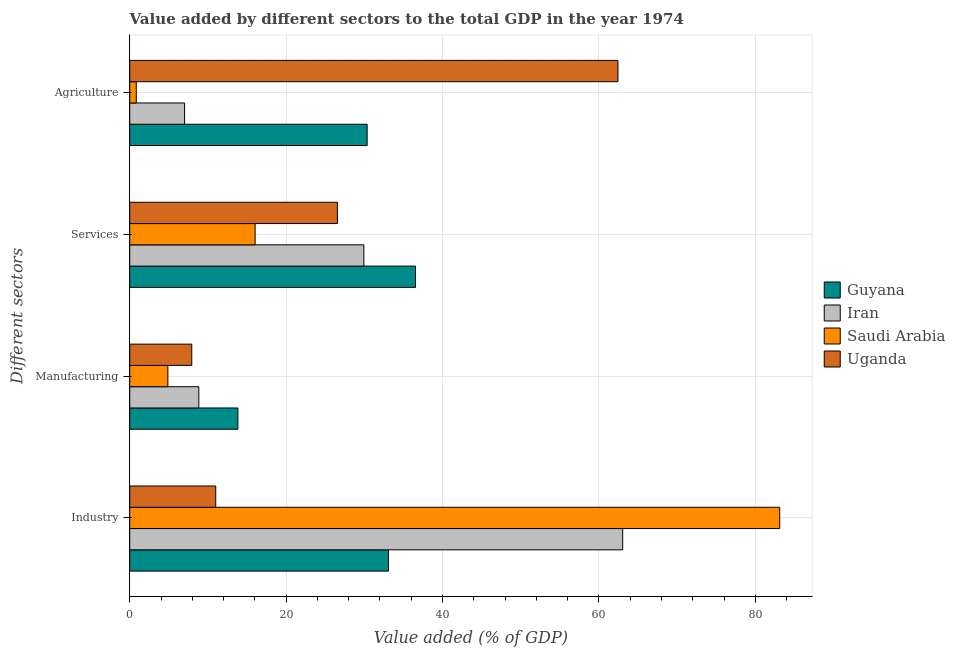How many different coloured bars are there?
Keep it short and to the point. 4. Are the number of bars on each tick of the Y-axis equal?
Your answer should be compact. Yes. How many bars are there on the 4th tick from the top?
Give a very brief answer. 4. How many bars are there on the 4th tick from the bottom?
Give a very brief answer. 4. What is the label of the 2nd group of bars from the top?
Give a very brief answer. Services. What is the value added by industrial sector in Saudi Arabia?
Offer a very short reply. 83.13. Across all countries, what is the maximum value added by services sector?
Keep it short and to the point. 36.55. Across all countries, what is the minimum value added by services sector?
Offer a terse response. 16.04. In which country was the value added by services sector maximum?
Offer a terse response. Guyana. In which country was the value added by manufacturing sector minimum?
Offer a terse response. Saudi Arabia. What is the total value added by services sector in the graph?
Your answer should be compact. 109.09. What is the difference between the value added by manufacturing sector in Saudi Arabia and that in Guyana?
Ensure brevity in your answer.  -8.95. What is the difference between the value added by manufacturing sector in Uganda and the value added by agricultural sector in Saudi Arabia?
Ensure brevity in your answer.  7.1. What is the average value added by services sector per country?
Your answer should be compact. 27.27. What is the difference between the value added by manufacturing sector and value added by agricultural sector in Uganda?
Your response must be concise. -54.5. What is the ratio of the value added by agricultural sector in Guyana to that in Uganda?
Ensure brevity in your answer.  0.49. Is the value added by industrial sector in Guyana less than that in Iran?
Your response must be concise. Yes. What is the difference between the highest and the second highest value added by industrial sector?
Provide a succinct answer. 20.08. What is the difference between the highest and the lowest value added by industrial sector?
Your response must be concise. 72.13. Is the sum of the value added by services sector in Uganda and Iran greater than the maximum value added by manufacturing sector across all countries?
Make the answer very short. Yes. What does the 4th bar from the top in Agriculture represents?
Your answer should be compact. Guyana. What does the 4th bar from the bottom in Agriculture represents?
Give a very brief answer. Uganda. Is it the case that in every country, the sum of the value added by industrial sector and value added by manufacturing sector is greater than the value added by services sector?
Ensure brevity in your answer.  No. How many bars are there?
Your response must be concise. 16. What is the difference between two consecutive major ticks on the X-axis?
Ensure brevity in your answer.  20. Are the values on the major ticks of X-axis written in scientific E-notation?
Provide a succinct answer. No. Does the graph contain any zero values?
Make the answer very short. No. Where does the legend appear in the graph?
Make the answer very short. Center right. How are the legend labels stacked?
Offer a terse response. Vertical. What is the title of the graph?
Make the answer very short. Value added by different sectors to the total GDP in the year 1974. What is the label or title of the X-axis?
Provide a succinct answer. Value added (% of GDP). What is the label or title of the Y-axis?
Make the answer very short. Different sectors. What is the Value added (% of GDP) of Guyana in Industry?
Provide a succinct answer. 33.09. What is the Value added (% of GDP) in Iran in Industry?
Offer a very short reply. 63.04. What is the Value added (% of GDP) in Saudi Arabia in Industry?
Your answer should be compact. 83.13. What is the Value added (% of GDP) in Uganda in Industry?
Keep it short and to the point. 11. What is the Value added (% of GDP) in Guyana in Manufacturing?
Make the answer very short. 13.83. What is the Value added (% of GDP) in Iran in Manufacturing?
Provide a succinct answer. 8.84. What is the Value added (% of GDP) in Saudi Arabia in Manufacturing?
Your answer should be very brief. 4.88. What is the Value added (% of GDP) of Uganda in Manufacturing?
Make the answer very short. 7.94. What is the Value added (% of GDP) in Guyana in Services?
Ensure brevity in your answer.  36.55. What is the Value added (% of GDP) in Iran in Services?
Your response must be concise. 29.94. What is the Value added (% of GDP) in Saudi Arabia in Services?
Offer a terse response. 16.04. What is the Value added (% of GDP) of Uganda in Services?
Provide a short and direct response. 26.56. What is the Value added (% of GDP) in Guyana in Agriculture?
Make the answer very short. 30.36. What is the Value added (% of GDP) in Iran in Agriculture?
Offer a terse response. 7.01. What is the Value added (% of GDP) in Saudi Arabia in Agriculture?
Keep it short and to the point. 0.84. What is the Value added (% of GDP) of Uganda in Agriculture?
Offer a very short reply. 62.44. Across all Different sectors, what is the maximum Value added (% of GDP) in Guyana?
Your answer should be compact. 36.55. Across all Different sectors, what is the maximum Value added (% of GDP) in Iran?
Offer a terse response. 63.04. Across all Different sectors, what is the maximum Value added (% of GDP) in Saudi Arabia?
Your answer should be very brief. 83.13. Across all Different sectors, what is the maximum Value added (% of GDP) in Uganda?
Offer a very short reply. 62.44. Across all Different sectors, what is the minimum Value added (% of GDP) of Guyana?
Ensure brevity in your answer.  13.83. Across all Different sectors, what is the minimum Value added (% of GDP) of Iran?
Your answer should be compact. 7.01. Across all Different sectors, what is the minimum Value added (% of GDP) in Saudi Arabia?
Offer a very short reply. 0.84. Across all Different sectors, what is the minimum Value added (% of GDP) in Uganda?
Provide a succinct answer. 7.94. What is the total Value added (% of GDP) of Guyana in the graph?
Keep it short and to the point. 113.83. What is the total Value added (% of GDP) in Iran in the graph?
Your answer should be compact. 108.84. What is the total Value added (% of GDP) in Saudi Arabia in the graph?
Offer a terse response. 104.88. What is the total Value added (% of GDP) in Uganda in the graph?
Your answer should be compact. 107.94. What is the difference between the Value added (% of GDP) in Guyana in Industry and that in Manufacturing?
Provide a short and direct response. 19.26. What is the difference between the Value added (% of GDP) of Iran in Industry and that in Manufacturing?
Make the answer very short. 54.21. What is the difference between the Value added (% of GDP) in Saudi Arabia in Industry and that in Manufacturing?
Your response must be concise. 78.25. What is the difference between the Value added (% of GDP) of Uganda in Industry and that in Manufacturing?
Your answer should be compact. 3.06. What is the difference between the Value added (% of GDP) of Guyana in Industry and that in Services?
Give a very brief answer. -3.46. What is the difference between the Value added (% of GDP) of Iran in Industry and that in Services?
Ensure brevity in your answer.  33.1. What is the difference between the Value added (% of GDP) of Saudi Arabia in Industry and that in Services?
Give a very brief answer. 67.09. What is the difference between the Value added (% of GDP) of Uganda in Industry and that in Services?
Keep it short and to the point. -15.56. What is the difference between the Value added (% of GDP) of Guyana in Industry and that in Agriculture?
Keep it short and to the point. 2.72. What is the difference between the Value added (% of GDP) in Iran in Industry and that in Agriculture?
Keep it short and to the point. 56.03. What is the difference between the Value added (% of GDP) in Saudi Arabia in Industry and that in Agriculture?
Make the answer very short. 82.29. What is the difference between the Value added (% of GDP) in Uganda in Industry and that in Agriculture?
Make the answer very short. -51.44. What is the difference between the Value added (% of GDP) of Guyana in Manufacturing and that in Services?
Offer a very short reply. -22.72. What is the difference between the Value added (% of GDP) in Iran in Manufacturing and that in Services?
Your response must be concise. -21.11. What is the difference between the Value added (% of GDP) of Saudi Arabia in Manufacturing and that in Services?
Give a very brief answer. -11.16. What is the difference between the Value added (% of GDP) in Uganda in Manufacturing and that in Services?
Make the answer very short. -18.62. What is the difference between the Value added (% of GDP) of Guyana in Manufacturing and that in Agriculture?
Your response must be concise. -16.53. What is the difference between the Value added (% of GDP) in Iran in Manufacturing and that in Agriculture?
Keep it short and to the point. 1.83. What is the difference between the Value added (% of GDP) in Saudi Arabia in Manufacturing and that in Agriculture?
Give a very brief answer. 4.04. What is the difference between the Value added (% of GDP) of Uganda in Manufacturing and that in Agriculture?
Make the answer very short. -54.5. What is the difference between the Value added (% of GDP) of Guyana in Services and that in Agriculture?
Your response must be concise. 6.19. What is the difference between the Value added (% of GDP) of Iran in Services and that in Agriculture?
Make the answer very short. 22.93. What is the difference between the Value added (% of GDP) of Saudi Arabia in Services and that in Agriculture?
Your answer should be very brief. 15.2. What is the difference between the Value added (% of GDP) of Uganda in Services and that in Agriculture?
Provide a succinct answer. -35.88. What is the difference between the Value added (% of GDP) of Guyana in Industry and the Value added (% of GDP) of Iran in Manufacturing?
Your answer should be compact. 24.25. What is the difference between the Value added (% of GDP) of Guyana in Industry and the Value added (% of GDP) of Saudi Arabia in Manufacturing?
Provide a succinct answer. 28.21. What is the difference between the Value added (% of GDP) of Guyana in Industry and the Value added (% of GDP) of Uganda in Manufacturing?
Keep it short and to the point. 25.15. What is the difference between the Value added (% of GDP) of Iran in Industry and the Value added (% of GDP) of Saudi Arabia in Manufacturing?
Give a very brief answer. 58.16. What is the difference between the Value added (% of GDP) in Iran in Industry and the Value added (% of GDP) in Uganda in Manufacturing?
Give a very brief answer. 55.11. What is the difference between the Value added (% of GDP) of Saudi Arabia in Industry and the Value added (% of GDP) of Uganda in Manufacturing?
Give a very brief answer. 75.19. What is the difference between the Value added (% of GDP) of Guyana in Industry and the Value added (% of GDP) of Iran in Services?
Your answer should be very brief. 3.14. What is the difference between the Value added (% of GDP) in Guyana in Industry and the Value added (% of GDP) in Saudi Arabia in Services?
Your response must be concise. 17.05. What is the difference between the Value added (% of GDP) in Guyana in Industry and the Value added (% of GDP) in Uganda in Services?
Keep it short and to the point. 6.53. What is the difference between the Value added (% of GDP) of Iran in Industry and the Value added (% of GDP) of Saudi Arabia in Services?
Make the answer very short. 47.01. What is the difference between the Value added (% of GDP) in Iran in Industry and the Value added (% of GDP) in Uganda in Services?
Offer a terse response. 36.48. What is the difference between the Value added (% of GDP) of Saudi Arabia in Industry and the Value added (% of GDP) of Uganda in Services?
Offer a terse response. 56.57. What is the difference between the Value added (% of GDP) in Guyana in Industry and the Value added (% of GDP) in Iran in Agriculture?
Ensure brevity in your answer.  26.08. What is the difference between the Value added (% of GDP) in Guyana in Industry and the Value added (% of GDP) in Saudi Arabia in Agriculture?
Make the answer very short. 32.25. What is the difference between the Value added (% of GDP) of Guyana in Industry and the Value added (% of GDP) of Uganda in Agriculture?
Offer a very short reply. -29.35. What is the difference between the Value added (% of GDP) of Iran in Industry and the Value added (% of GDP) of Saudi Arabia in Agriculture?
Your response must be concise. 62.21. What is the difference between the Value added (% of GDP) in Iran in Industry and the Value added (% of GDP) in Uganda in Agriculture?
Keep it short and to the point. 0.61. What is the difference between the Value added (% of GDP) in Saudi Arabia in Industry and the Value added (% of GDP) in Uganda in Agriculture?
Make the answer very short. 20.69. What is the difference between the Value added (% of GDP) in Guyana in Manufacturing and the Value added (% of GDP) in Iran in Services?
Provide a short and direct response. -16.11. What is the difference between the Value added (% of GDP) of Guyana in Manufacturing and the Value added (% of GDP) of Saudi Arabia in Services?
Offer a terse response. -2.21. What is the difference between the Value added (% of GDP) in Guyana in Manufacturing and the Value added (% of GDP) in Uganda in Services?
Your response must be concise. -12.73. What is the difference between the Value added (% of GDP) in Iran in Manufacturing and the Value added (% of GDP) in Saudi Arabia in Services?
Offer a very short reply. -7.2. What is the difference between the Value added (% of GDP) of Iran in Manufacturing and the Value added (% of GDP) of Uganda in Services?
Your answer should be compact. -17.72. What is the difference between the Value added (% of GDP) of Saudi Arabia in Manufacturing and the Value added (% of GDP) of Uganda in Services?
Make the answer very short. -21.68. What is the difference between the Value added (% of GDP) of Guyana in Manufacturing and the Value added (% of GDP) of Iran in Agriculture?
Ensure brevity in your answer.  6.82. What is the difference between the Value added (% of GDP) of Guyana in Manufacturing and the Value added (% of GDP) of Saudi Arabia in Agriculture?
Your answer should be very brief. 13. What is the difference between the Value added (% of GDP) of Guyana in Manufacturing and the Value added (% of GDP) of Uganda in Agriculture?
Keep it short and to the point. -48.61. What is the difference between the Value added (% of GDP) in Iran in Manufacturing and the Value added (% of GDP) in Saudi Arabia in Agriculture?
Provide a short and direct response. 8. What is the difference between the Value added (% of GDP) of Iran in Manufacturing and the Value added (% of GDP) of Uganda in Agriculture?
Ensure brevity in your answer.  -53.6. What is the difference between the Value added (% of GDP) in Saudi Arabia in Manufacturing and the Value added (% of GDP) in Uganda in Agriculture?
Ensure brevity in your answer.  -57.56. What is the difference between the Value added (% of GDP) of Guyana in Services and the Value added (% of GDP) of Iran in Agriculture?
Offer a terse response. 29.54. What is the difference between the Value added (% of GDP) in Guyana in Services and the Value added (% of GDP) in Saudi Arabia in Agriculture?
Your response must be concise. 35.71. What is the difference between the Value added (% of GDP) of Guyana in Services and the Value added (% of GDP) of Uganda in Agriculture?
Offer a very short reply. -25.89. What is the difference between the Value added (% of GDP) in Iran in Services and the Value added (% of GDP) in Saudi Arabia in Agriculture?
Your answer should be compact. 29.11. What is the difference between the Value added (% of GDP) of Iran in Services and the Value added (% of GDP) of Uganda in Agriculture?
Offer a terse response. -32.5. What is the difference between the Value added (% of GDP) of Saudi Arabia in Services and the Value added (% of GDP) of Uganda in Agriculture?
Your answer should be very brief. -46.4. What is the average Value added (% of GDP) of Guyana per Different sectors?
Make the answer very short. 28.46. What is the average Value added (% of GDP) in Iran per Different sectors?
Ensure brevity in your answer.  27.21. What is the average Value added (% of GDP) of Saudi Arabia per Different sectors?
Provide a succinct answer. 26.22. What is the average Value added (% of GDP) of Uganda per Different sectors?
Your answer should be very brief. 26.98. What is the difference between the Value added (% of GDP) in Guyana and Value added (% of GDP) in Iran in Industry?
Ensure brevity in your answer.  -29.96. What is the difference between the Value added (% of GDP) of Guyana and Value added (% of GDP) of Saudi Arabia in Industry?
Give a very brief answer. -50.04. What is the difference between the Value added (% of GDP) in Guyana and Value added (% of GDP) in Uganda in Industry?
Give a very brief answer. 22.09. What is the difference between the Value added (% of GDP) of Iran and Value added (% of GDP) of Saudi Arabia in Industry?
Provide a succinct answer. -20.08. What is the difference between the Value added (% of GDP) in Iran and Value added (% of GDP) in Uganda in Industry?
Give a very brief answer. 52.04. What is the difference between the Value added (% of GDP) of Saudi Arabia and Value added (% of GDP) of Uganda in Industry?
Provide a short and direct response. 72.13. What is the difference between the Value added (% of GDP) of Guyana and Value added (% of GDP) of Iran in Manufacturing?
Offer a terse response. 4.99. What is the difference between the Value added (% of GDP) in Guyana and Value added (% of GDP) in Saudi Arabia in Manufacturing?
Offer a terse response. 8.95. What is the difference between the Value added (% of GDP) of Guyana and Value added (% of GDP) of Uganda in Manufacturing?
Give a very brief answer. 5.89. What is the difference between the Value added (% of GDP) in Iran and Value added (% of GDP) in Saudi Arabia in Manufacturing?
Make the answer very short. 3.96. What is the difference between the Value added (% of GDP) of Iran and Value added (% of GDP) of Uganda in Manufacturing?
Your answer should be compact. 0.9. What is the difference between the Value added (% of GDP) in Saudi Arabia and Value added (% of GDP) in Uganda in Manufacturing?
Your answer should be compact. -3.06. What is the difference between the Value added (% of GDP) in Guyana and Value added (% of GDP) in Iran in Services?
Ensure brevity in your answer.  6.61. What is the difference between the Value added (% of GDP) of Guyana and Value added (% of GDP) of Saudi Arabia in Services?
Provide a succinct answer. 20.51. What is the difference between the Value added (% of GDP) of Guyana and Value added (% of GDP) of Uganda in Services?
Give a very brief answer. 9.99. What is the difference between the Value added (% of GDP) in Iran and Value added (% of GDP) in Saudi Arabia in Services?
Keep it short and to the point. 13.91. What is the difference between the Value added (% of GDP) of Iran and Value added (% of GDP) of Uganda in Services?
Your answer should be compact. 3.38. What is the difference between the Value added (% of GDP) in Saudi Arabia and Value added (% of GDP) in Uganda in Services?
Keep it short and to the point. -10.52. What is the difference between the Value added (% of GDP) in Guyana and Value added (% of GDP) in Iran in Agriculture?
Your response must be concise. 23.35. What is the difference between the Value added (% of GDP) of Guyana and Value added (% of GDP) of Saudi Arabia in Agriculture?
Your response must be concise. 29.53. What is the difference between the Value added (% of GDP) in Guyana and Value added (% of GDP) in Uganda in Agriculture?
Keep it short and to the point. -32.08. What is the difference between the Value added (% of GDP) in Iran and Value added (% of GDP) in Saudi Arabia in Agriculture?
Ensure brevity in your answer.  6.18. What is the difference between the Value added (% of GDP) in Iran and Value added (% of GDP) in Uganda in Agriculture?
Keep it short and to the point. -55.43. What is the difference between the Value added (% of GDP) of Saudi Arabia and Value added (% of GDP) of Uganda in Agriculture?
Your response must be concise. -61.6. What is the ratio of the Value added (% of GDP) in Guyana in Industry to that in Manufacturing?
Make the answer very short. 2.39. What is the ratio of the Value added (% of GDP) in Iran in Industry to that in Manufacturing?
Your answer should be very brief. 7.13. What is the ratio of the Value added (% of GDP) in Saudi Arabia in Industry to that in Manufacturing?
Offer a very short reply. 17.04. What is the ratio of the Value added (% of GDP) in Uganda in Industry to that in Manufacturing?
Offer a terse response. 1.39. What is the ratio of the Value added (% of GDP) of Guyana in Industry to that in Services?
Offer a very short reply. 0.91. What is the ratio of the Value added (% of GDP) of Iran in Industry to that in Services?
Keep it short and to the point. 2.11. What is the ratio of the Value added (% of GDP) in Saudi Arabia in Industry to that in Services?
Make the answer very short. 5.18. What is the ratio of the Value added (% of GDP) in Uganda in Industry to that in Services?
Ensure brevity in your answer.  0.41. What is the ratio of the Value added (% of GDP) of Guyana in Industry to that in Agriculture?
Provide a short and direct response. 1.09. What is the ratio of the Value added (% of GDP) of Iran in Industry to that in Agriculture?
Provide a succinct answer. 8.99. What is the ratio of the Value added (% of GDP) of Saudi Arabia in Industry to that in Agriculture?
Your answer should be compact. 99.49. What is the ratio of the Value added (% of GDP) of Uganda in Industry to that in Agriculture?
Keep it short and to the point. 0.18. What is the ratio of the Value added (% of GDP) in Guyana in Manufacturing to that in Services?
Offer a terse response. 0.38. What is the ratio of the Value added (% of GDP) in Iran in Manufacturing to that in Services?
Make the answer very short. 0.3. What is the ratio of the Value added (% of GDP) in Saudi Arabia in Manufacturing to that in Services?
Provide a succinct answer. 0.3. What is the ratio of the Value added (% of GDP) of Uganda in Manufacturing to that in Services?
Ensure brevity in your answer.  0.3. What is the ratio of the Value added (% of GDP) in Guyana in Manufacturing to that in Agriculture?
Your answer should be compact. 0.46. What is the ratio of the Value added (% of GDP) in Iran in Manufacturing to that in Agriculture?
Give a very brief answer. 1.26. What is the ratio of the Value added (% of GDP) of Saudi Arabia in Manufacturing to that in Agriculture?
Your answer should be compact. 5.84. What is the ratio of the Value added (% of GDP) of Uganda in Manufacturing to that in Agriculture?
Your answer should be very brief. 0.13. What is the ratio of the Value added (% of GDP) of Guyana in Services to that in Agriculture?
Your answer should be very brief. 1.2. What is the ratio of the Value added (% of GDP) in Iran in Services to that in Agriculture?
Your response must be concise. 4.27. What is the ratio of the Value added (% of GDP) in Saudi Arabia in Services to that in Agriculture?
Keep it short and to the point. 19.19. What is the ratio of the Value added (% of GDP) in Uganda in Services to that in Agriculture?
Your response must be concise. 0.43. What is the difference between the highest and the second highest Value added (% of GDP) in Guyana?
Offer a terse response. 3.46. What is the difference between the highest and the second highest Value added (% of GDP) of Iran?
Your answer should be very brief. 33.1. What is the difference between the highest and the second highest Value added (% of GDP) of Saudi Arabia?
Keep it short and to the point. 67.09. What is the difference between the highest and the second highest Value added (% of GDP) of Uganda?
Offer a terse response. 35.88. What is the difference between the highest and the lowest Value added (% of GDP) of Guyana?
Offer a terse response. 22.72. What is the difference between the highest and the lowest Value added (% of GDP) of Iran?
Provide a short and direct response. 56.03. What is the difference between the highest and the lowest Value added (% of GDP) of Saudi Arabia?
Offer a very short reply. 82.29. What is the difference between the highest and the lowest Value added (% of GDP) of Uganda?
Make the answer very short. 54.5. 